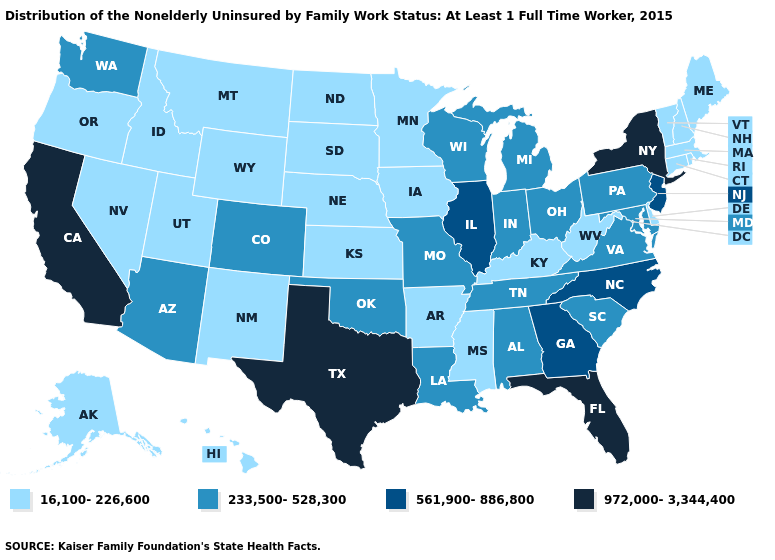Does West Virginia have the lowest value in the USA?
Short answer required. Yes. Name the states that have a value in the range 561,900-886,800?
Short answer required. Georgia, Illinois, New Jersey, North Carolina. What is the value of Arizona?
Write a very short answer. 233,500-528,300. What is the lowest value in states that border Tennessee?
Quick response, please. 16,100-226,600. Name the states that have a value in the range 972,000-3,344,400?
Give a very brief answer. California, Florida, New York, Texas. Does Wyoming have a lower value than Utah?
Answer briefly. No. Name the states that have a value in the range 972,000-3,344,400?
Keep it brief. California, Florida, New York, Texas. What is the value of Illinois?
Be succinct. 561,900-886,800. Which states have the lowest value in the South?
Answer briefly. Arkansas, Delaware, Kentucky, Mississippi, West Virginia. Name the states that have a value in the range 561,900-886,800?
Quick response, please. Georgia, Illinois, New Jersey, North Carolina. What is the value of Mississippi?
Concise answer only. 16,100-226,600. Which states have the lowest value in the USA?
Keep it brief. Alaska, Arkansas, Connecticut, Delaware, Hawaii, Idaho, Iowa, Kansas, Kentucky, Maine, Massachusetts, Minnesota, Mississippi, Montana, Nebraska, Nevada, New Hampshire, New Mexico, North Dakota, Oregon, Rhode Island, South Dakota, Utah, Vermont, West Virginia, Wyoming. Which states have the lowest value in the USA?
Short answer required. Alaska, Arkansas, Connecticut, Delaware, Hawaii, Idaho, Iowa, Kansas, Kentucky, Maine, Massachusetts, Minnesota, Mississippi, Montana, Nebraska, Nevada, New Hampshire, New Mexico, North Dakota, Oregon, Rhode Island, South Dakota, Utah, Vermont, West Virginia, Wyoming. Which states have the highest value in the USA?
Write a very short answer. California, Florida, New York, Texas. Does the map have missing data?
Answer briefly. No. 